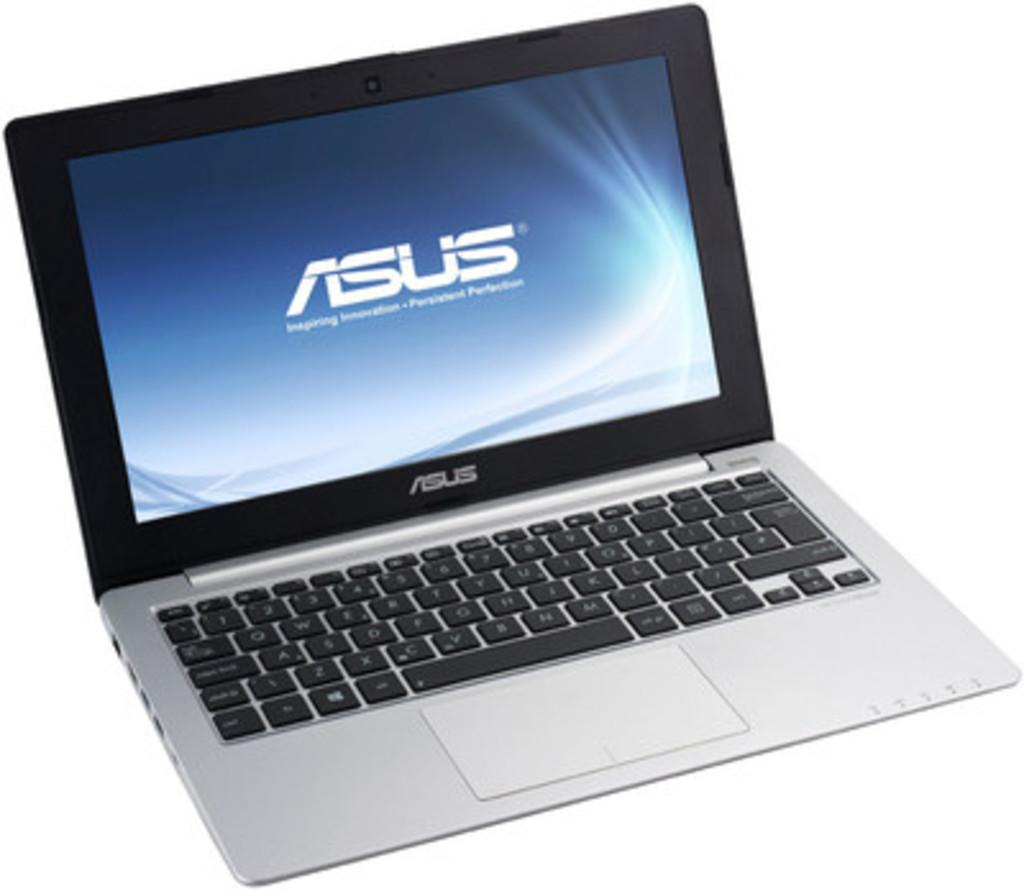<image>
Render a clear and concise summary of the photo. An ASUS laptop with the lid open and the body of the laptop being silver and black in color. 